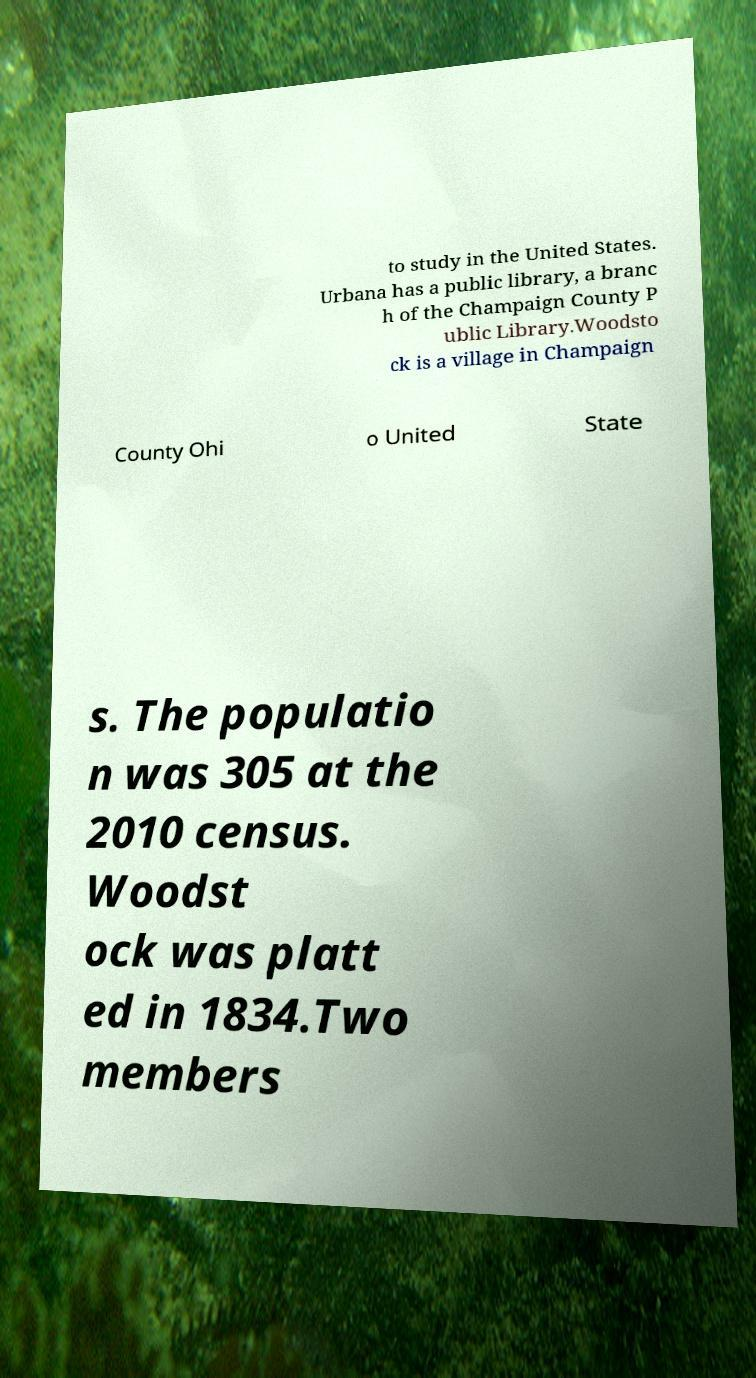Can you read and provide the text displayed in the image?This photo seems to have some interesting text. Can you extract and type it out for me? to study in the United States. Urbana has a public library, a branc h of the Champaign County P ublic Library.Woodsto ck is a village in Champaign County Ohi o United State s. The populatio n was 305 at the 2010 census. Woodst ock was platt ed in 1834.Two members 